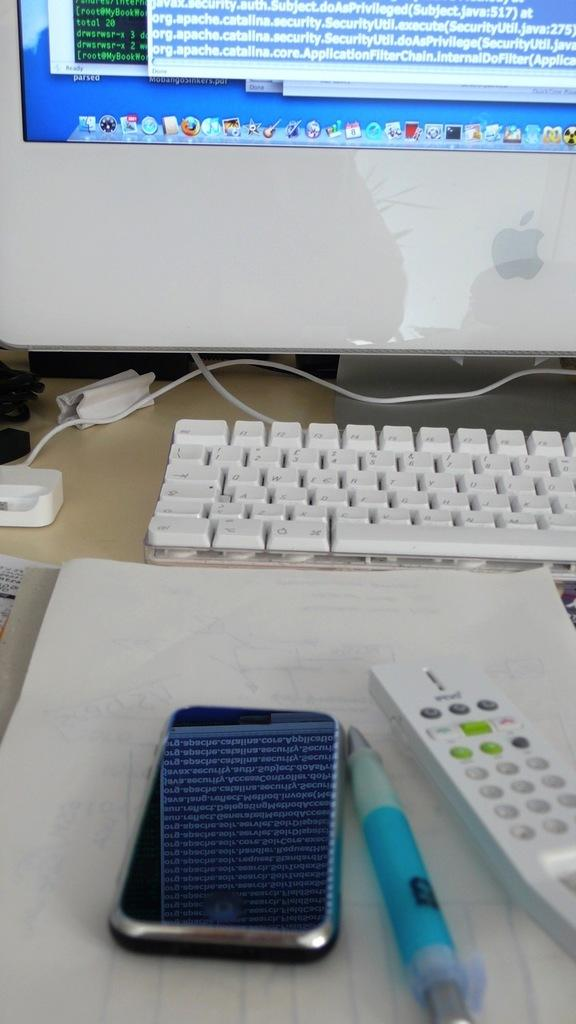What electronic device is on the table in the image? There is a computer on the table in the image. What other items can be seen on the table? There is a mobile, a remote, a pen, wires, and a book on the table. What might be used for controlling electronic devices in the image? The remote on the table might be used for controlling electronic devices. What might be used for writing in the image? The pen on the table might be used for writing. What type of guitar can be seen in the image? There is no guitar present in the image. Is there a birthday celebration happening in the image? There is no indication of a birthday celebration in the image. 